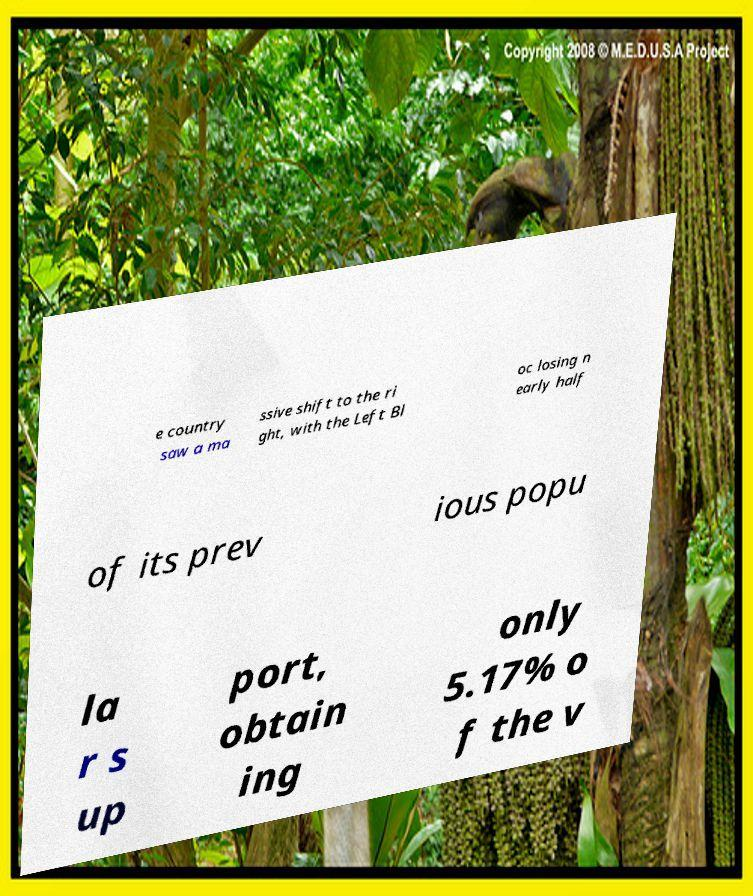Can you accurately transcribe the text from the provided image for me? e country saw a ma ssive shift to the ri ght, with the Left Bl oc losing n early half of its prev ious popu la r s up port, obtain ing only 5.17% o f the v 